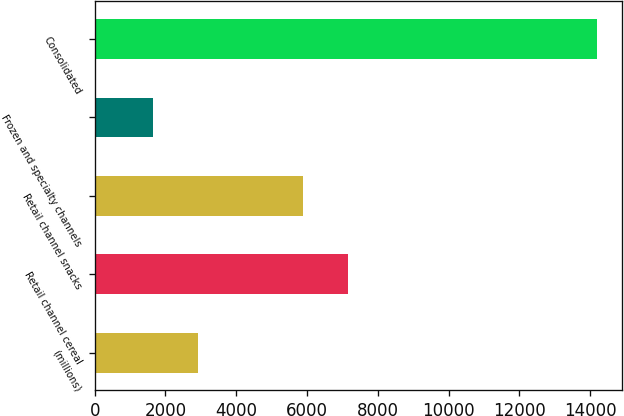Convert chart to OTSL. <chart><loc_0><loc_0><loc_500><loc_500><bar_chart><fcel>(millions)<fcel>Retail channel cereal<fcel>Retail channel snacks<fcel>Frozen and specialty channels<fcel>Consolidated<nl><fcel>2908.3<fcel>7145.3<fcel>5891<fcel>1654<fcel>14197<nl></chart> 